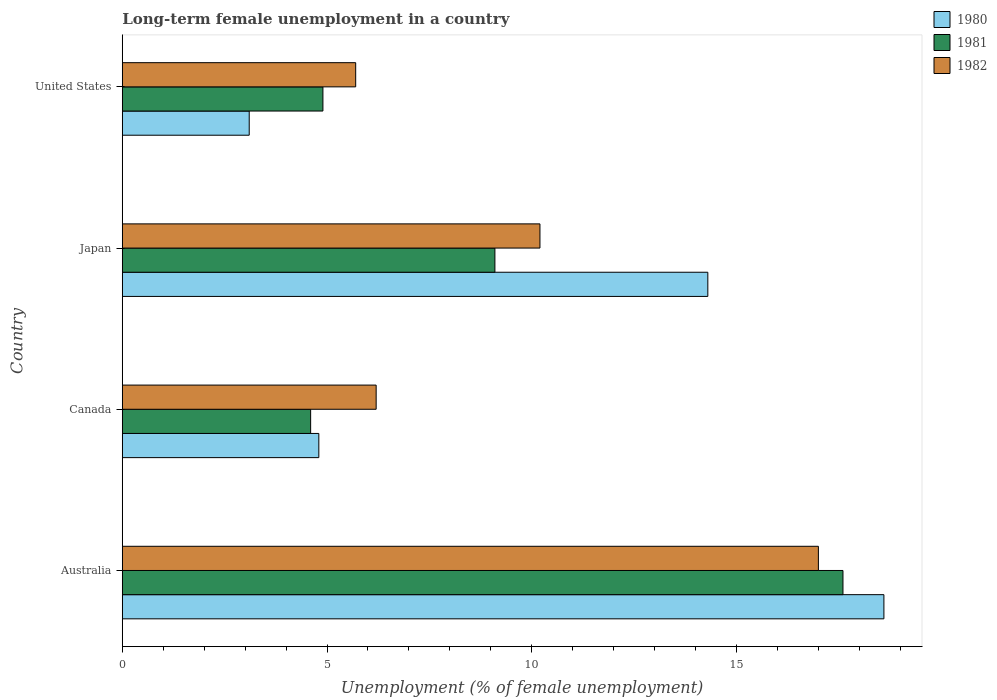Are the number of bars per tick equal to the number of legend labels?
Your answer should be compact. Yes. Are the number of bars on each tick of the Y-axis equal?
Your response must be concise. Yes. How many bars are there on the 2nd tick from the top?
Give a very brief answer. 3. What is the label of the 4th group of bars from the top?
Your answer should be compact. Australia. What is the percentage of long-term unemployed female population in 1980 in Canada?
Ensure brevity in your answer.  4.8. Across all countries, what is the maximum percentage of long-term unemployed female population in 1981?
Your response must be concise. 17.6. Across all countries, what is the minimum percentage of long-term unemployed female population in 1981?
Offer a terse response. 4.6. In which country was the percentage of long-term unemployed female population in 1981 minimum?
Offer a very short reply. Canada. What is the total percentage of long-term unemployed female population in 1982 in the graph?
Your answer should be compact. 39.1. What is the difference between the percentage of long-term unemployed female population in 1982 in Canada and that in Japan?
Your response must be concise. -4. What is the difference between the percentage of long-term unemployed female population in 1982 in United States and the percentage of long-term unemployed female population in 1981 in Australia?
Keep it short and to the point. -11.9. What is the average percentage of long-term unemployed female population in 1980 per country?
Give a very brief answer. 10.2. What is the difference between the percentage of long-term unemployed female population in 1980 and percentage of long-term unemployed female population in 1982 in Australia?
Keep it short and to the point. 1.6. In how many countries, is the percentage of long-term unemployed female population in 1981 greater than 1 %?
Your answer should be compact. 4. What is the ratio of the percentage of long-term unemployed female population in 1981 in Japan to that in United States?
Make the answer very short. 1.86. Is the difference between the percentage of long-term unemployed female population in 1980 in Australia and Japan greater than the difference between the percentage of long-term unemployed female population in 1982 in Australia and Japan?
Your response must be concise. No. What is the difference between the highest and the second highest percentage of long-term unemployed female population in 1981?
Your answer should be very brief. 8.5. What is the difference between the highest and the lowest percentage of long-term unemployed female population in 1982?
Offer a terse response. 11.3. In how many countries, is the percentage of long-term unemployed female population in 1981 greater than the average percentage of long-term unemployed female population in 1981 taken over all countries?
Provide a short and direct response. 2. Is the sum of the percentage of long-term unemployed female population in 1980 in Australia and Canada greater than the maximum percentage of long-term unemployed female population in 1981 across all countries?
Ensure brevity in your answer.  Yes. What does the 3rd bar from the top in Canada represents?
Keep it short and to the point. 1980. What does the 3rd bar from the bottom in United States represents?
Ensure brevity in your answer.  1982. How many bars are there?
Offer a very short reply. 12. Are the values on the major ticks of X-axis written in scientific E-notation?
Offer a terse response. No. Does the graph contain any zero values?
Ensure brevity in your answer.  No. Does the graph contain grids?
Make the answer very short. No. How are the legend labels stacked?
Keep it short and to the point. Vertical. What is the title of the graph?
Your answer should be compact. Long-term female unemployment in a country. Does "2015" appear as one of the legend labels in the graph?
Keep it short and to the point. No. What is the label or title of the X-axis?
Offer a very short reply. Unemployment (% of female unemployment). What is the Unemployment (% of female unemployment) of 1980 in Australia?
Your answer should be very brief. 18.6. What is the Unemployment (% of female unemployment) in 1981 in Australia?
Offer a terse response. 17.6. What is the Unemployment (% of female unemployment) of 1982 in Australia?
Offer a very short reply. 17. What is the Unemployment (% of female unemployment) of 1980 in Canada?
Your answer should be compact. 4.8. What is the Unemployment (% of female unemployment) in 1981 in Canada?
Offer a very short reply. 4.6. What is the Unemployment (% of female unemployment) of 1982 in Canada?
Give a very brief answer. 6.2. What is the Unemployment (% of female unemployment) of 1980 in Japan?
Offer a terse response. 14.3. What is the Unemployment (% of female unemployment) of 1981 in Japan?
Your answer should be compact. 9.1. What is the Unemployment (% of female unemployment) in 1982 in Japan?
Keep it short and to the point. 10.2. What is the Unemployment (% of female unemployment) in 1980 in United States?
Give a very brief answer. 3.1. What is the Unemployment (% of female unemployment) in 1981 in United States?
Offer a very short reply. 4.9. What is the Unemployment (% of female unemployment) of 1982 in United States?
Offer a terse response. 5.7. Across all countries, what is the maximum Unemployment (% of female unemployment) in 1980?
Your response must be concise. 18.6. Across all countries, what is the maximum Unemployment (% of female unemployment) in 1981?
Give a very brief answer. 17.6. Across all countries, what is the minimum Unemployment (% of female unemployment) in 1980?
Your answer should be compact. 3.1. Across all countries, what is the minimum Unemployment (% of female unemployment) in 1981?
Offer a terse response. 4.6. Across all countries, what is the minimum Unemployment (% of female unemployment) of 1982?
Make the answer very short. 5.7. What is the total Unemployment (% of female unemployment) in 1980 in the graph?
Your response must be concise. 40.8. What is the total Unemployment (% of female unemployment) of 1981 in the graph?
Your answer should be compact. 36.2. What is the total Unemployment (% of female unemployment) of 1982 in the graph?
Provide a short and direct response. 39.1. What is the difference between the Unemployment (% of female unemployment) of 1980 in Australia and that in United States?
Provide a succinct answer. 15.5. What is the difference between the Unemployment (% of female unemployment) in 1981 in Australia and that in United States?
Ensure brevity in your answer.  12.7. What is the difference between the Unemployment (% of female unemployment) of 1982 in Australia and that in United States?
Provide a succinct answer. 11.3. What is the difference between the Unemployment (% of female unemployment) in 1980 in Canada and that in United States?
Provide a succinct answer. 1.7. What is the difference between the Unemployment (% of female unemployment) in 1982 in Canada and that in United States?
Give a very brief answer. 0.5. What is the difference between the Unemployment (% of female unemployment) of 1980 in Japan and that in United States?
Provide a short and direct response. 11.2. What is the difference between the Unemployment (% of female unemployment) of 1981 in Japan and that in United States?
Keep it short and to the point. 4.2. What is the difference between the Unemployment (% of female unemployment) in 1982 in Japan and that in United States?
Make the answer very short. 4.5. What is the difference between the Unemployment (% of female unemployment) of 1980 in Australia and the Unemployment (% of female unemployment) of 1981 in Japan?
Provide a succinct answer. 9.5. What is the difference between the Unemployment (% of female unemployment) in 1980 in Australia and the Unemployment (% of female unemployment) in 1982 in Japan?
Your answer should be compact. 8.4. What is the difference between the Unemployment (% of female unemployment) of 1980 in Australia and the Unemployment (% of female unemployment) of 1982 in United States?
Your response must be concise. 12.9. What is the difference between the Unemployment (% of female unemployment) in 1981 in Australia and the Unemployment (% of female unemployment) in 1982 in United States?
Make the answer very short. 11.9. What is the difference between the Unemployment (% of female unemployment) of 1981 in Canada and the Unemployment (% of female unemployment) of 1982 in Japan?
Make the answer very short. -5.6. What is the difference between the Unemployment (% of female unemployment) of 1980 in Canada and the Unemployment (% of female unemployment) of 1981 in United States?
Make the answer very short. -0.1. What is the difference between the Unemployment (% of female unemployment) in 1980 in Japan and the Unemployment (% of female unemployment) in 1981 in United States?
Provide a short and direct response. 9.4. What is the difference between the Unemployment (% of female unemployment) of 1980 in Japan and the Unemployment (% of female unemployment) of 1982 in United States?
Provide a short and direct response. 8.6. What is the difference between the Unemployment (% of female unemployment) in 1981 in Japan and the Unemployment (% of female unemployment) in 1982 in United States?
Your answer should be compact. 3.4. What is the average Unemployment (% of female unemployment) of 1981 per country?
Keep it short and to the point. 9.05. What is the average Unemployment (% of female unemployment) in 1982 per country?
Give a very brief answer. 9.78. What is the difference between the Unemployment (% of female unemployment) of 1980 and Unemployment (% of female unemployment) of 1981 in Australia?
Offer a very short reply. 1. What is the difference between the Unemployment (% of female unemployment) in 1981 and Unemployment (% of female unemployment) in 1982 in Australia?
Provide a short and direct response. 0.6. What is the difference between the Unemployment (% of female unemployment) of 1980 and Unemployment (% of female unemployment) of 1981 in Japan?
Offer a very short reply. 5.2. What is the difference between the Unemployment (% of female unemployment) in 1980 and Unemployment (% of female unemployment) in 1982 in United States?
Your answer should be compact. -2.6. What is the ratio of the Unemployment (% of female unemployment) of 1980 in Australia to that in Canada?
Your answer should be compact. 3.88. What is the ratio of the Unemployment (% of female unemployment) in 1981 in Australia to that in Canada?
Offer a terse response. 3.83. What is the ratio of the Unemployment (% of female unemployment) of 1982 in Australia to that in Canada?
Your response must be concise. 2.74. What is the ratio of the Unemployment (% of female unemployment) in 1980 in Australia to that in Japan?
Keep it short and to the point. 1.3. What is the ratio of the Unemployment (% of female unemployment) in 1981 in Australia to that in Japan?
Keep it short and to the point. 1.93. What is the ratio of the Unemployment (% of female unemployment) of 1981 in Australia to that in United States?
Provide a succinct answer. 3.59. What is the ratio of the Unemployment (% of female unemployment) in 1982 in Australia to that in United States?
Your answer should be very brief. 2.98. What is the ratio of the Unemployment (% of female unemployment) in 1980 in Canada to that in Japan?
Your answer should be compact. 0.34. What is the ratio of the Unemployment (% of female unemployment) of 1981 in Canada to that in Japan?
Make the answer very short. 0.51. What is the ratio of the Unemployment (% of female unemployment) in 1982 in Canada to that in Japan?
Give a very brief answer. 0.61. What is the ratio of the Unemployment (% of female unemployment) of 1980 in Canada to that in United States?
Ensure brevity in your answer.  1.55. What is the ratio of the Unemployment (% of female unemployment) of 1981 in Canada to that in United States?
Ensure brevity in your answer.  0.94. What is the ratio of the Unemployment (% of female unemployment) of 1982 in Canada to that in United States?
Make the answer very short. 1.09. What is the ratio of the Unemployment (% of female unemployment) in 1980 in Japan to that in United States?
Make the answer very short. 4.61. What is the ratio of the Unemployment (% of female unemployment) of 1981 in Japan to that in United States?
Offer a very short reply. 1.86. What is the ratio of the Unemployment (% of female unemployment) in 1982 in Japan to that in United States?
Keep it short and to the point. 1.79. What is the difference between the highest and the second highest Unemployment (% of female unemployment) of 1980?
Your answer should be very brief. 4.3. 